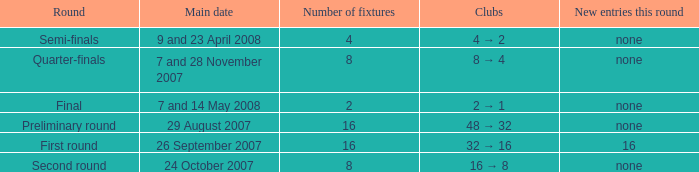What is the New entries this round when the round is the semi-finals? None. 